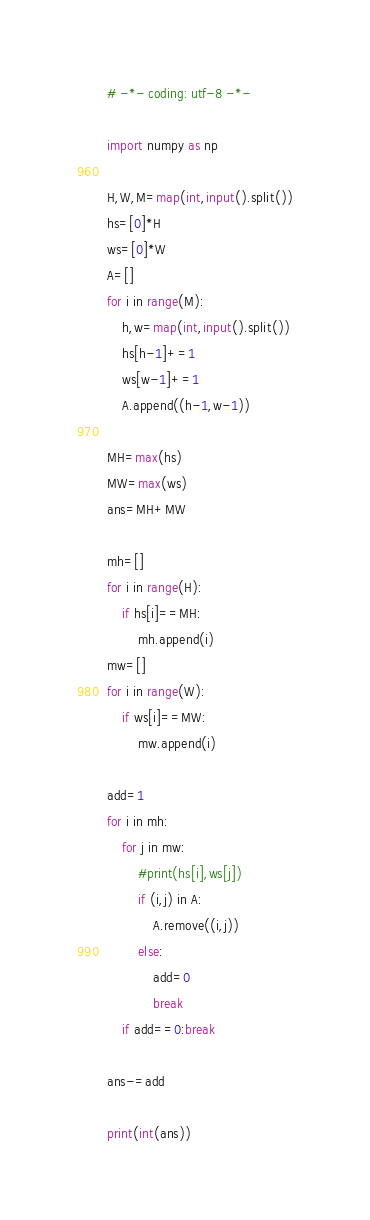Convert code to text. <code><loc_0><loc_0><loc_500><loc_500><_Python_># -*- coding: utf-8 -*-

import numpy as np

H,W,M=map(int,input().split())
hs=[0]*H
ws=[0]*W
A=[]
for i in range(M):
    h,w=map(int,input().split())
    hs[h-1]+=1
    ws[w-1]+=1
    A.append((h-1,w-1))

MH=max(hs)
MW=max(ws)
ans=MH+MW

mh=[]
for i in range(H):
    if hs[i]==MH:
        mh.append(i)
mw=[]
for i in range(W):
    if ws[i]==MW:
        mw.append(i)

add=1
for i in mh:
    for j in mw:
        #print(hs[i],ws[j])
        if (i,j) in A:
            A.remove((i,j))
        else:
            add=0
            break
    if add==0:break

ans-=add

print(int(ans))

</code> 